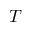<formula> <loc_0><loc_0><loc_500><loc_500>T</formula> 